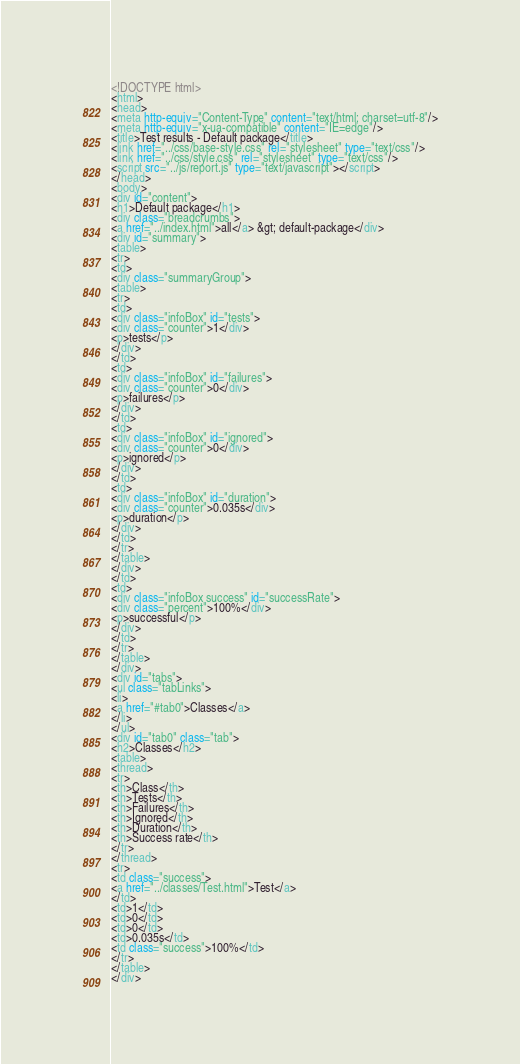<code> <loc_0><loc_0><loc_500><loc_500><_HTML_><!DOCTYPE html>
<html>
<head>
<meta http-equiv="Content-Type" content="text/html; charset=utf-8"/>
<meta http-equiv="x-ua-compatible" content="IE=edge"/>
<title>Test results - Default package</title>
<link href="../css/base-style.css" rel="stylesheet" type="text/css"/>
<link href="../css/style.css" rel="stylesheet" type="text/css"/>
<script src="../js/report.js" type="text/javascript"></script>
</head>
<body>
<div id="content">
<h1>Default package</h1>
<div class="breadcrumbs">
<a href="../index.html">all</a> &gt; default-package</div>
<div id="summary">
<table>
<tr>
<td>
<div class="summaryGroup">
<table>
<tr>
<td>
<div class="infoBox" id="tests">
<div class="counter">1</div>
<p>tests</p>
</div>
</td>
<td>
<div class="infoBox" id="failures">
<div class="counter">0</div>
<p>failures</p>
</div>
</td>
<td>
<div class="infoBox" id="ignored">
<div class="counter">0</div>
<p>ignored</p>
</div>
</td>
<td>
<div class="infoBox" id="duration">
<div class="counter">0.035s</div>
<p>duration</p>
</div>
</td>
</tr>
</table>
</div>
</td>
<td>
<div class="infoBox success" id="successRate">
<div class="percent">100%</div>
<p>successful</p>
</div>
</td>
</tr>
</table>
</div>
<div id="tabs">
<ul class="tabLinks">
<li>
<a href="#tab0">Classes</a>
</li>
</ul>
<div id="tab0" class="tab">
<h2>Classes</h2>
<table>
<thread>
<tr>
<th>Class</th>
<th>Tests</th>
<th>Failures</th>
<th>Ignored</th>
<th>Duration</th>
<th>Success rate</th>
</tr>
</thread>
<tr>
<td class="success">
<a href="../classes/Test.html">Test</a>
</td>
<td>1</td>
<td>0</td>
<td>0</td>
<td>0.035s</td>
<td class="success">100%</td>
</tr>
</table>
</div></code> 